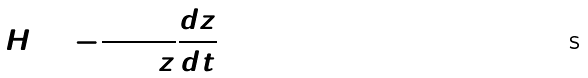<formula> <loc_0><loc_0><loc_500><loc_500>H = - \frac { 1 } { 1 + z } \frac { d z } { d t }</formula> 